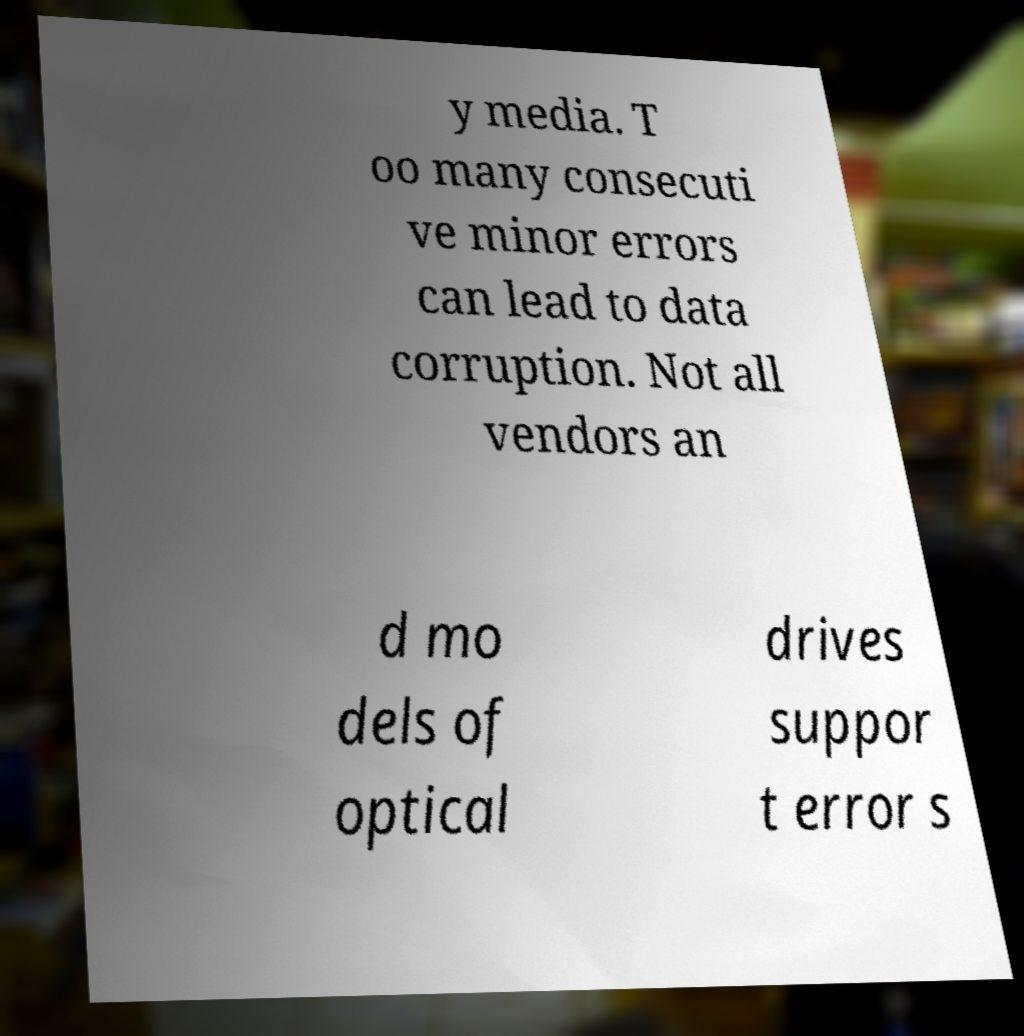There's text embedded in this image that I need extracted. Can you transcribe it verbatim? y media. T oo many consecuti ve minor errors can lead to data corruption. Not all vendors an d mo dels of optical drives suppor t error s 